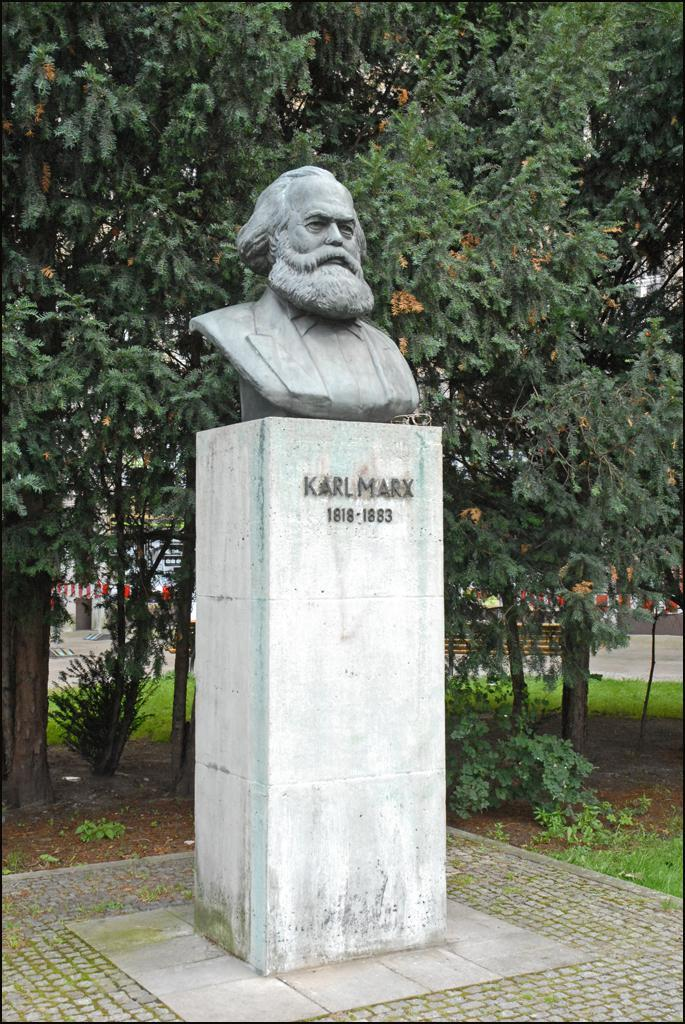What is the main subject of the image? There is a person statue in the image. Where is the statue located? The statue is on a concrete-stand. What can be found on the statue? There is writing on the statue. What can be seen in the background of the image? There are trees and other objects in the background of the image. How many clovers are growing on the statue in the image? There are no clovers present on the statue or in the image. 